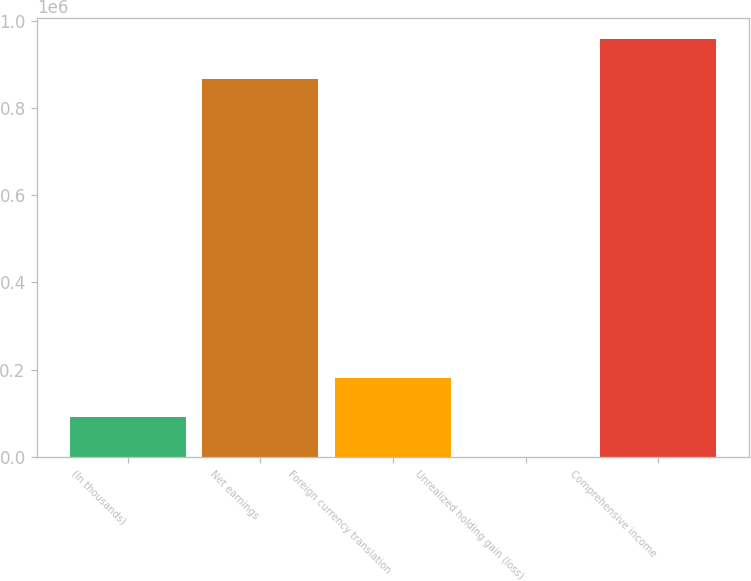<chart> <loc_0><loc_0><loc_500><loc_500><bar_chart><fcel>(In thousands)<fcel>Net earnings<fcel>Foreign currency translation<fcel>Unrealized holding gain (loss)<fcel>Comprehensive income<nl><fcel>90988.1<fcel>866978<fcel>181296<fcel>680<fcel>957286<nl></chart> 